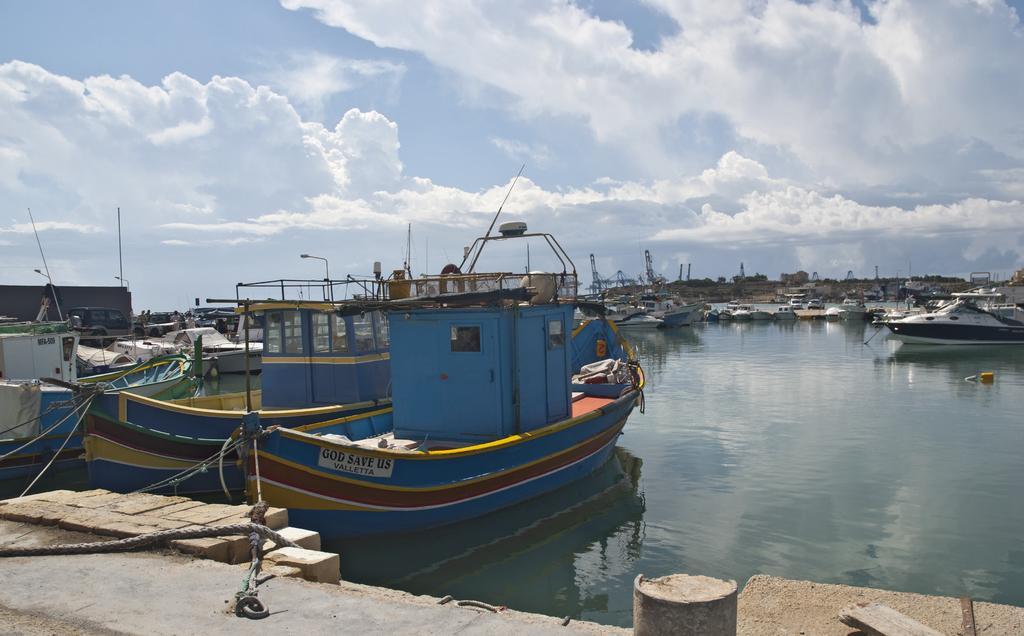Could you give a brief overview of what you see in this image? In this image there is a sea, on that sea there are boats, in the background there is a cloudy sky. 